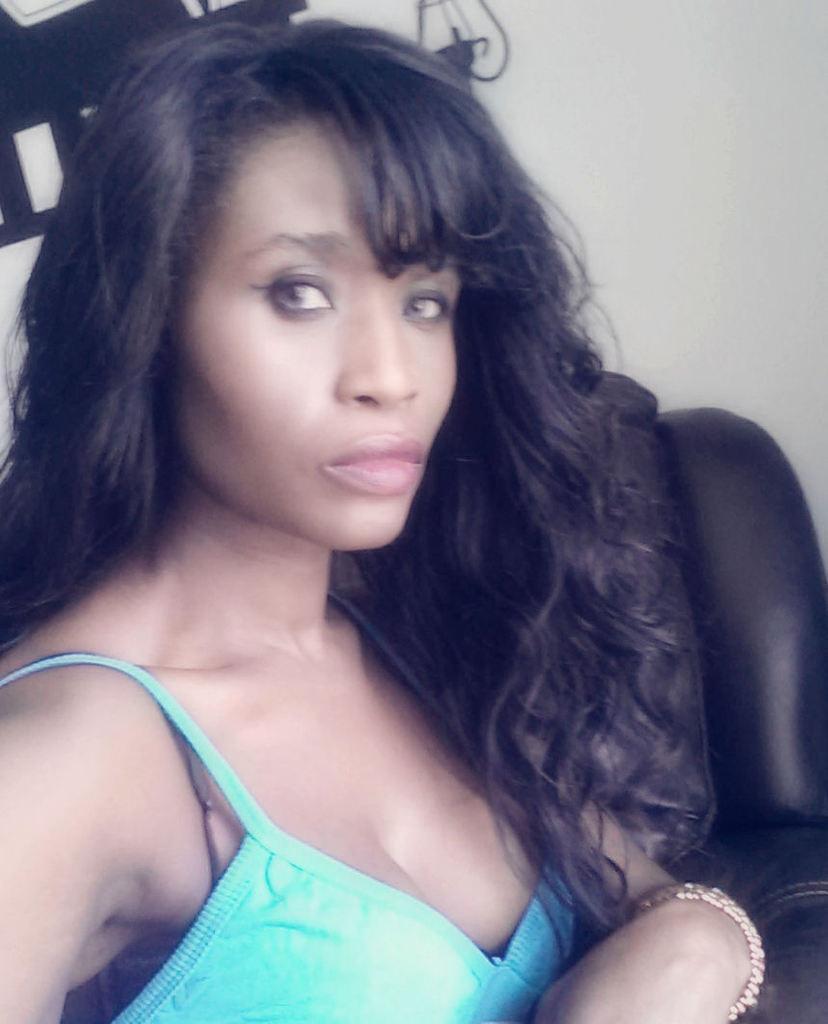Please provide a concise description of this image. In the middle of the image a woman is sitting on the couch. In the background there is a wall with a painting on it. 